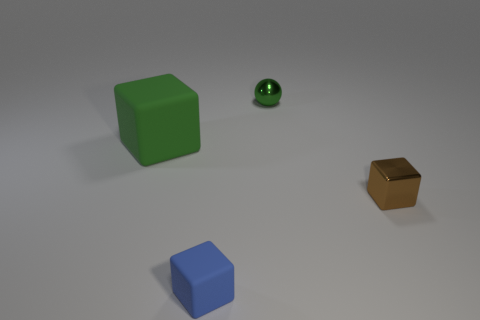What is the size of the green shiny ball? The green shiny ball in the image appears to be relatively small, especially when compared to the other objects surrounding it, such as the larger green cube and the smaller golden cube. 